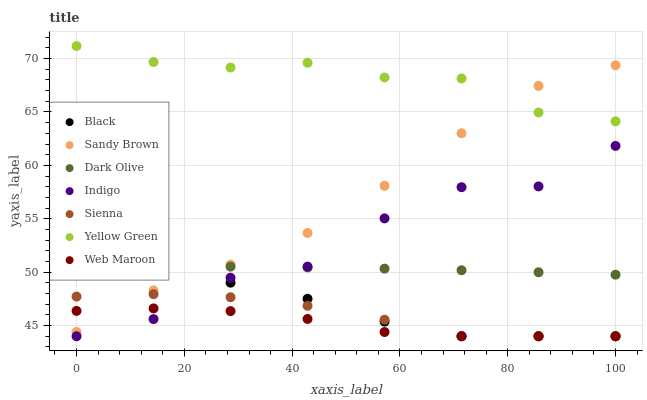Does Web Maroon have the minimum area under the curve?
Answer yes or no. Yes. Does Yellow Green have the maximum area under the curve?
Answer yes or no. Yes. Does Dark Olive have the minimum area under the curve?
Answer yes or no. No. Does Dark Olive have the maximum area under the curve?
Answer yes or no. No. Is Dark Olive the smoothest?
Answer yes or no. Yes. Is Indigo the roughest?
Answer yes or no. Yes. Is Yellow Green the smoothest?
Answer yes or no. No. Is Yellow Green the roughest?
Answer yes or no. No. Does Indigo have the lowest value?
Answer yes or no. Yes. Does Dark Olive have the lowest value?
Answer yes or no. No. Does Yellow Green have the highest value?
Answer yes or no. Yes. Does Dark Olive have the highest value?
Answer yes or no. No. Is Black less than Dark Olive?
Answer yes or no. Yes. Is Yellow Green greater than Indigo?
Answer yes or no. Yes. Does Sienna intersect Indigo?
Answer yes or no. Yes. Is Sienna less than Indigo?
Answer yes or no. No. Is Sienna greater than Indigo?
Answer yes or no. No. Does Black intersect Dark Olive?
Answer yes or no. No. 